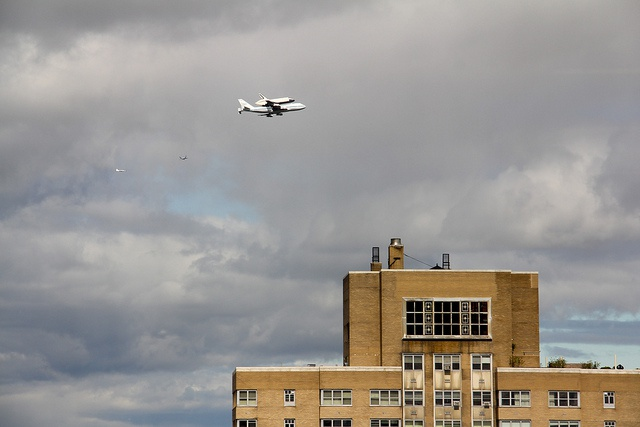Describe the objects in this image and their specific colors. I can see airplane in gray, white, black, and darkgray tones, airplane in darkgray, white, gray, and lightgray tones, and airplane in darkgray and gray tones in this image. 